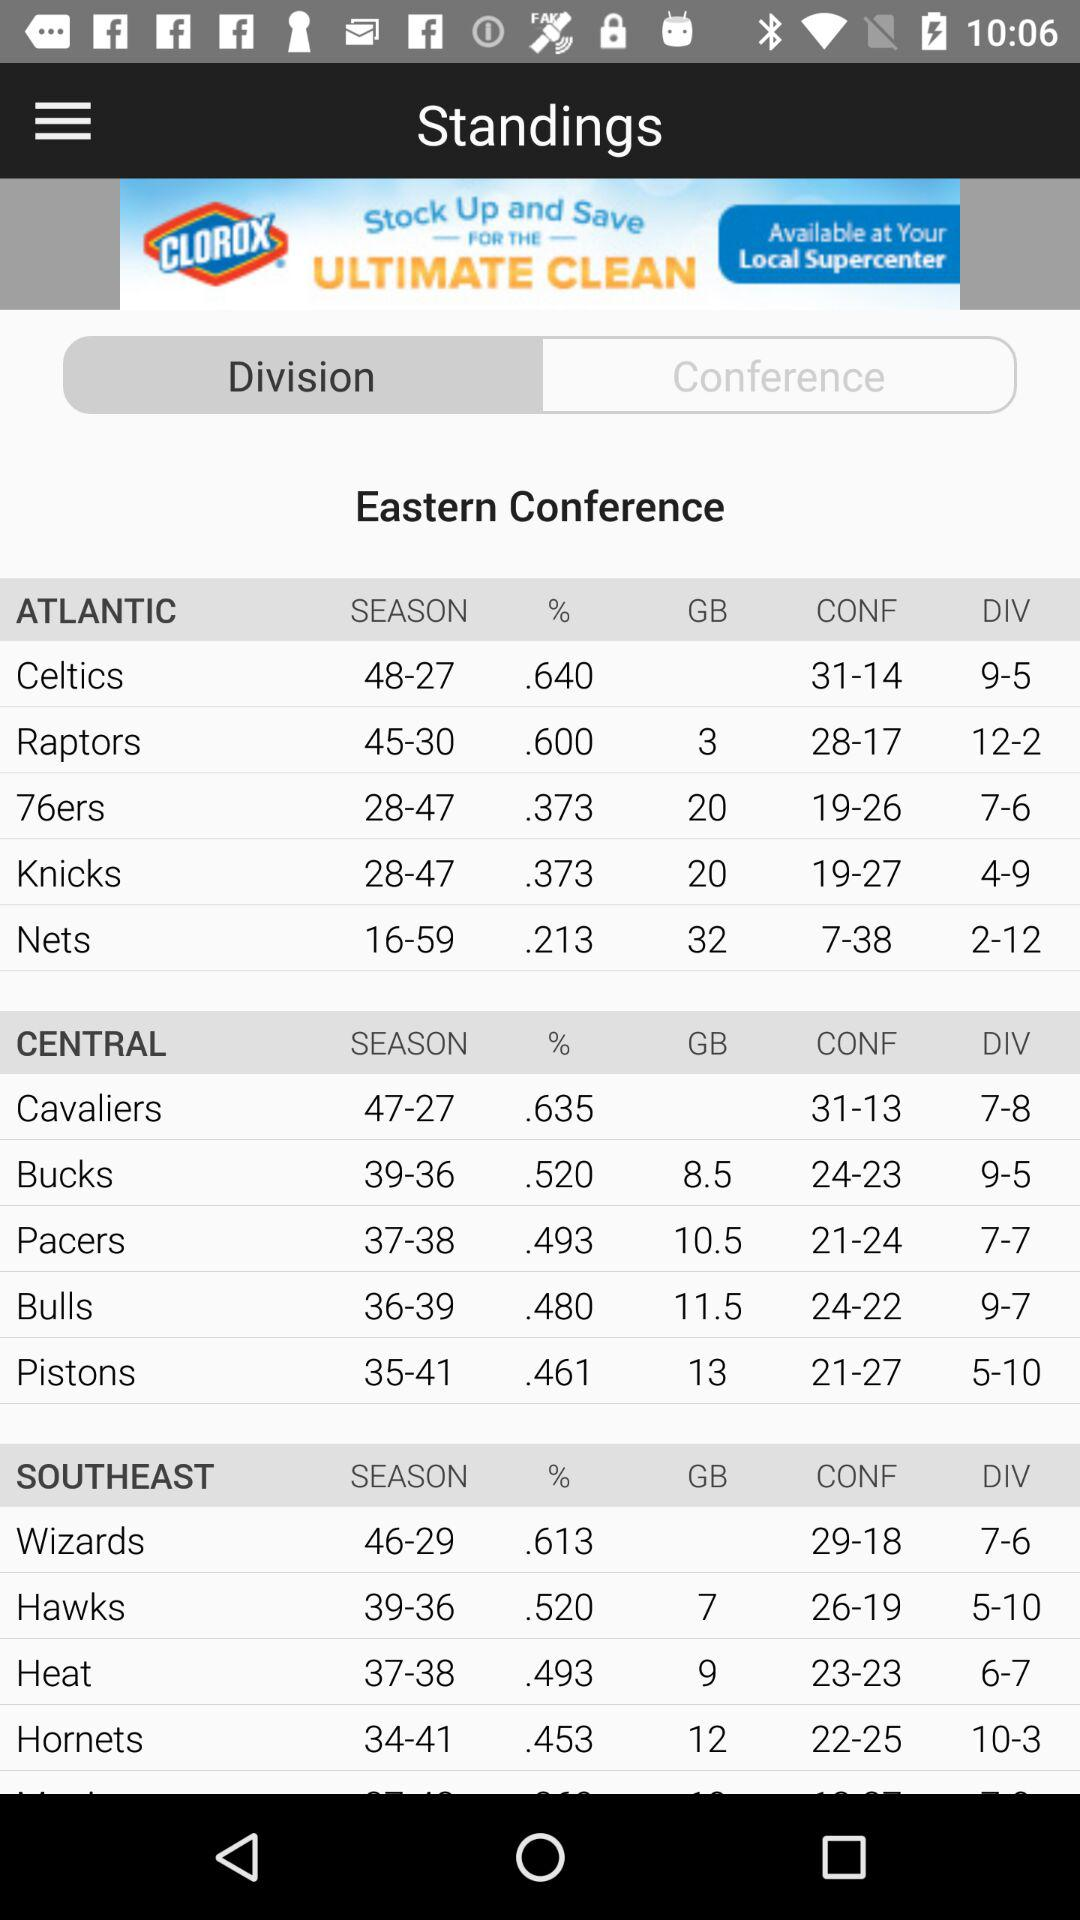What is the percentage of "Pacers"?
Answer the question using a single word or phrase. It is.493%. 